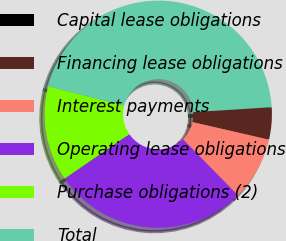Convert chart to OTSL. <chart><loc_0><loc_0><loc_500><loc_500><pie_chart><fcel>Capital lease obligations<fcel>Financing lease obligations<fcel>Interest payments<fcel>Operating lease obligations<fcel>Purchase obligations (2)<fcel>Total<nl><fcel>0.05%<fcel>4.55%<fcel>9.05%<fcel>27.77%<fcel>13.55%<fcel>45.05%<nl></chart> 